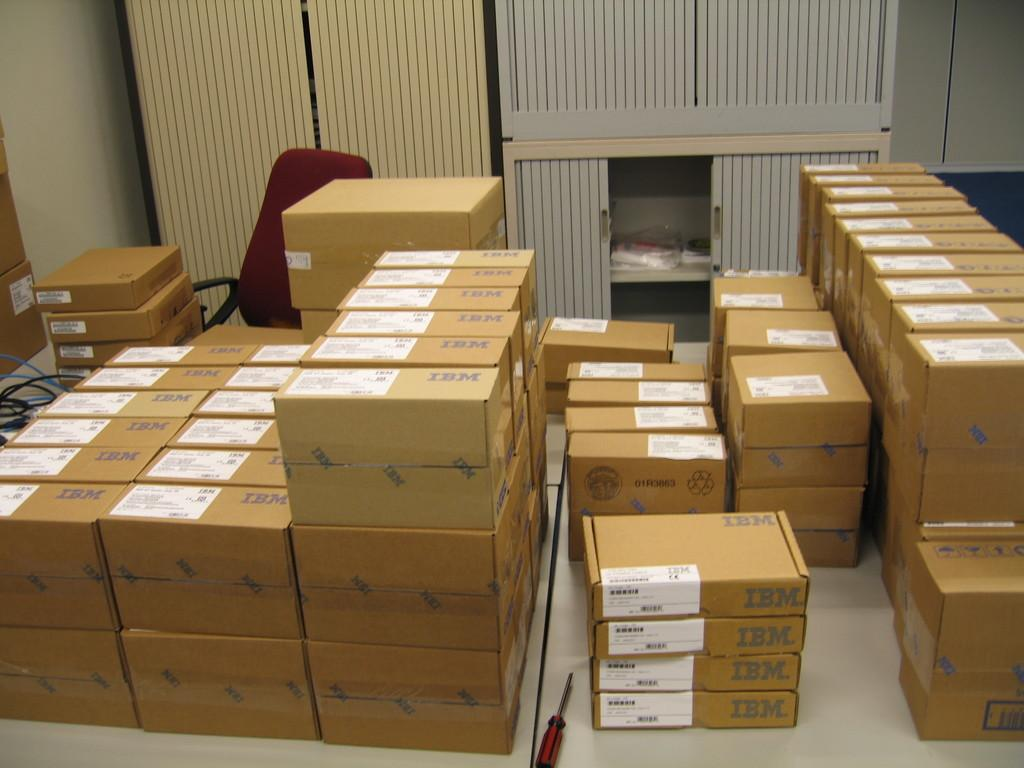<image>
Give a short and clear explanation of the subsequent image. A pile of boxes labeled IBM in a room. 